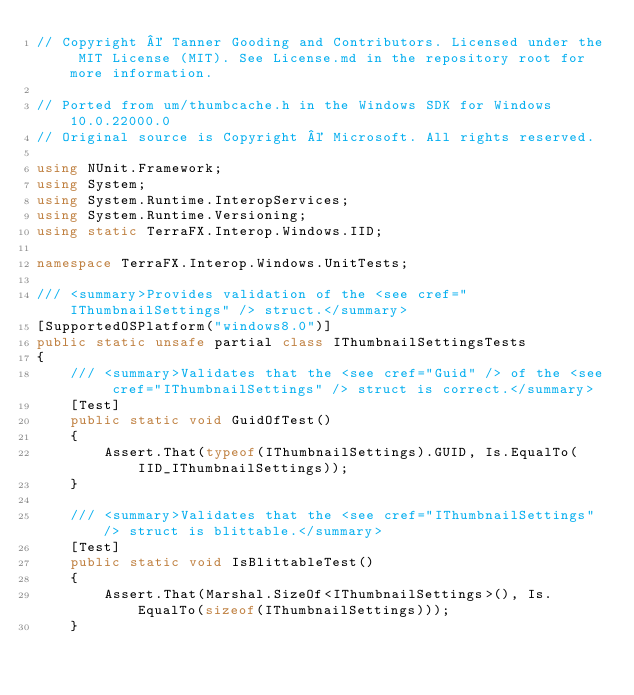<code> <loc_0><loc_0><loc_500><loc_500><_C#_>// Copyright © Tanner Gooding and Contributors. Licensed under the MIT License (MIT). See License.md in the repository root for more information.

// Ported from um/thumbcache.h in the Windows SDK for Windows 10.0.22000.0
// Original source is Copyright © Microsoft. All rights reserved.

using NUnit.Framework;
using System;
using System.Runtime.InteropServices;
using System.Runtime.Versioning;
using static TerraFX.Interop.Windows.IID;

namespace TerraFX.Interop.Windows.UnitTests;

/// <summary>Provides validation of the <see cref="IThumbnailSettings" /> struct.</summary>
[SupportedOSPlatform("windows8.0")]
public static unsafe partial class IThumbnailSettingsTests
{
    /// <summary>Validates that the <see cref="Guid" /> of the <see cref="IThumbnailSettings" /> struct is correct.</summary>
    [Test]
    public static void GuidOfTest()
    {
        Assert.That(typeof(IThumbnailSettings).GUID, Is.EqualTo(IID_IThumbnailSettings));
    }

    /// <summary>Validates that the <see cref="IThumbnailSettings" /> struct is blittable.</summary>
    [Test]
    public static void IsBlittableTest()
    {
        Assert.That(Marshal.SizeOf<IThumbnailSettings>(), Is.EqualTo(sizeof(IThumbnailSettings)));
    }
</code> 